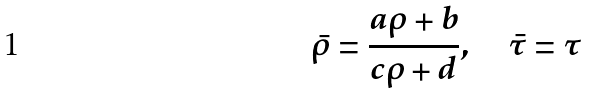<formula> <loc_0><loc_0><loc_500><loc_500>\bar { \rho } = \frac { a \rho + b } { c \rho + d } , \quad \bar { \tau } = \tau</formula> 